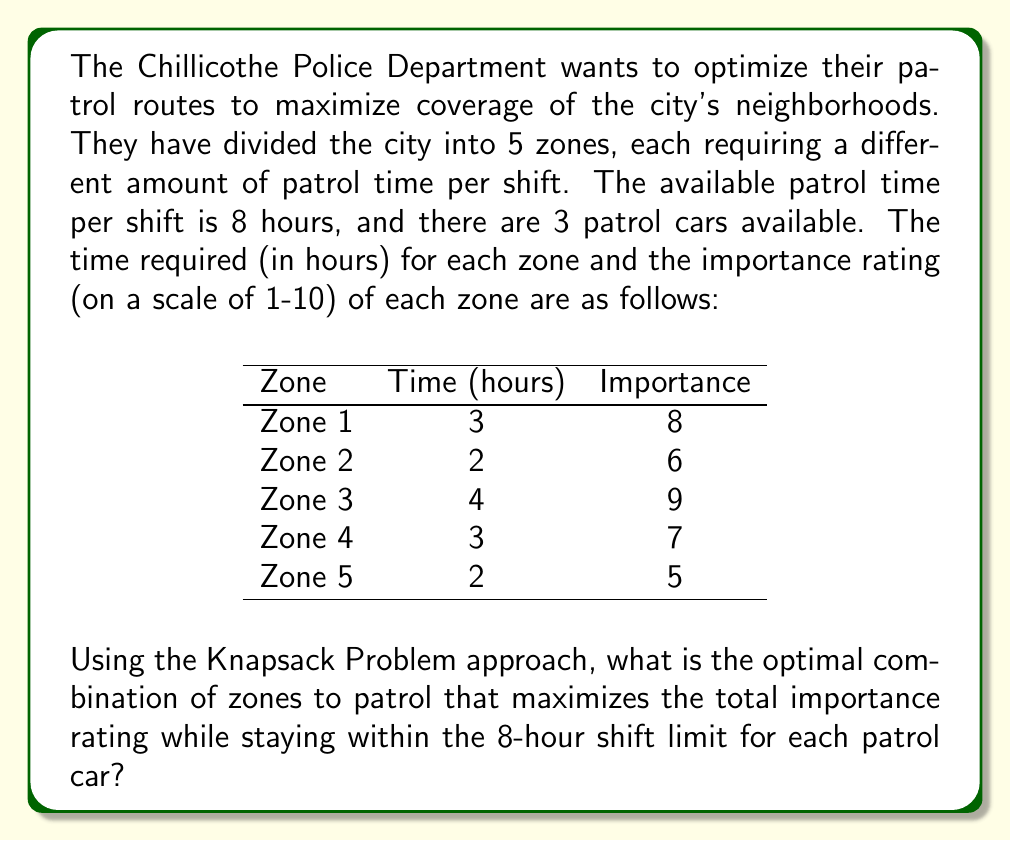Teach me how to tackle this problem. To solve this problem, we'll use the 0-1 Knapsack Problem approach. Here's how we'll proceed:

1) First, let's define our variables:
   $x_i$ = 1 if zone i is patrolled, 0 otherwise
   $w_i$ = time required for zone i
   $v_i$ = importance rating of zone i

2) Our objective function is to maximize the total importance:
   $\text{Maximize } \sum_{i=1}^5 v_i x_i$

3) Subject to the constraint:
   $\sum_{i=1}^5 w_i x_i \leq 8$ (time constraint for each patrol car)

4) We'll create a table to solve this problem:

   | Zone (i) | Time ($w_i$) | Importance ($v_i$) | $v_i/w_i$ |
   |----------|--------------|---------------------|-----------|
   | 1        | 3            | 8                   | 2.67      |
   | 2        | 2            | 6                   | 3.00      |
   | 3        | 4            | 9                   | 2.25      |
   | 4        | 3            | 7                   | 2.33      |
   | 5        | 2            | 5                   | 2.50      |

5) We'll sort the zones by $v_i/w_i$ in descending order:
   Zone 2, Zone 1, Zone 5, Zone 4, Zone 3

6) Now, we'll start selecting zones in this order until we reach the time limit:
   Zone 2: 2 hours, importance 6
   Zone 1: 2 + 3 = 5 hours, importance 6 + 8 = 14
   Zone 5: 5 + 2 = 7 hours, importance 14 + 5 = 19
   Zone 4: 7 + 3 = 10 hours (exceeds limit)
   Zone 3: 7 + 4 = 11 hours (exceeds limit)

7) Therefore, the optimal combination is to patrol Zones 2, 1, and 5.

8) This solution uses 7 hours of the 8-hour shift and achieves a total importance rating of 19.

9) For the remaining two patrol cars, they can follow the same route or be assigned to specific zones based on real-time needs.
Answer: The optimal combination of zones to patrol is Zones 2, 1, and 5, which achieves a total importance rating of 19 while using 7 hours of the 8-hour shift. 